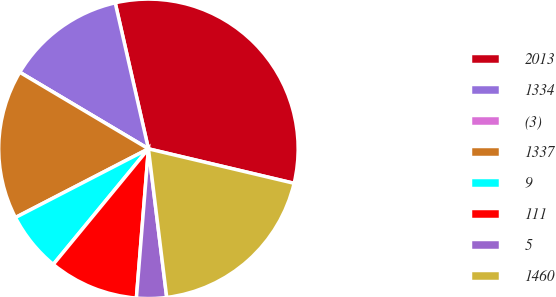Convert chart. <chart><loc_0><loc_0><loc_500><loc_500><pie_chart><fcel>2013<fcel>1334<fcel>(3)<fcel>1337<fcel>9<fcel>111<fcel>5<fcel>1460<nl><fcel>32.26%<fcel>12.9%<fcel>0.0%<fcel>16.13%<fcel>6.45%<fcel>9.68%<fcel>3.23%<fcel>19.35%<nl></chart> 